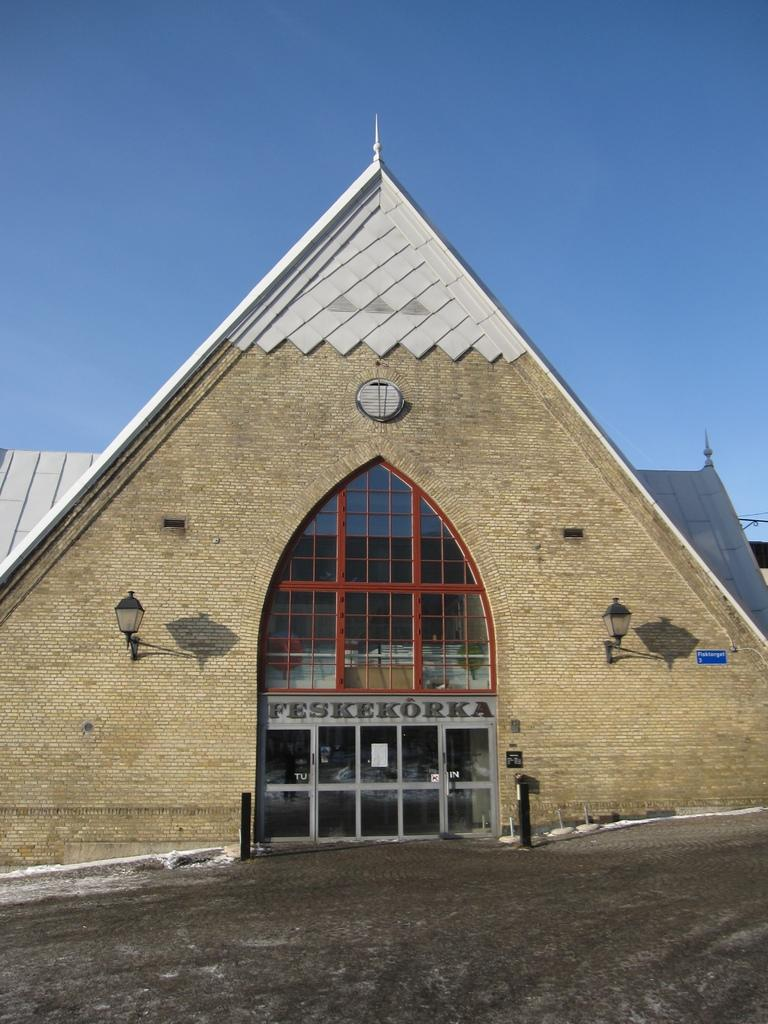What type of structure is visible in the image? There is a building in the image. What is written on the boards in the image? There are boards with text in the image. What are the poles used for in the image? The poles are likely used for supporting lights or other objects in the image. What type of illumination is present in the image? There are lights in the image. Can you describe the object in the image? There is an object in the image, but its specific purpose or appearance is not clear from the provided facts. What can be seen in the background of the image? The sky is visible in the background of the image. What type of stew is being served in the image? There is no stew present in the image; it features a building, boards with text, poles, lights, and an object. Is the image based on a fictional story or event? The image itself is not described as being based on a fictional story or event, so we cannot definitively answer this question. 